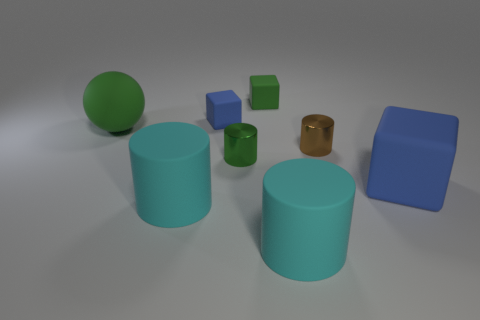Add 1 tiny blue matte blocks. How many objects exist? 9 Subtract all balls. How many objects are left? 7 Subtract all large cyan cylinders. Subtract all green shiny objects. How many objects are left? 5 Add 3 large green things. How many large green things are left? 4 Add 2 tiny purple spheres. How many tiny purple spheres exist? 2 Subtract 0 red spheres. How many objects are left? 8 